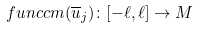Convert formula to latex. <formula><loc_0><loc_0><loc_500><loc_500>\ f u n c { c m } ( \overline { u } _ { j } ) \colon [ - \ell , \ell ] \to M</formula> 